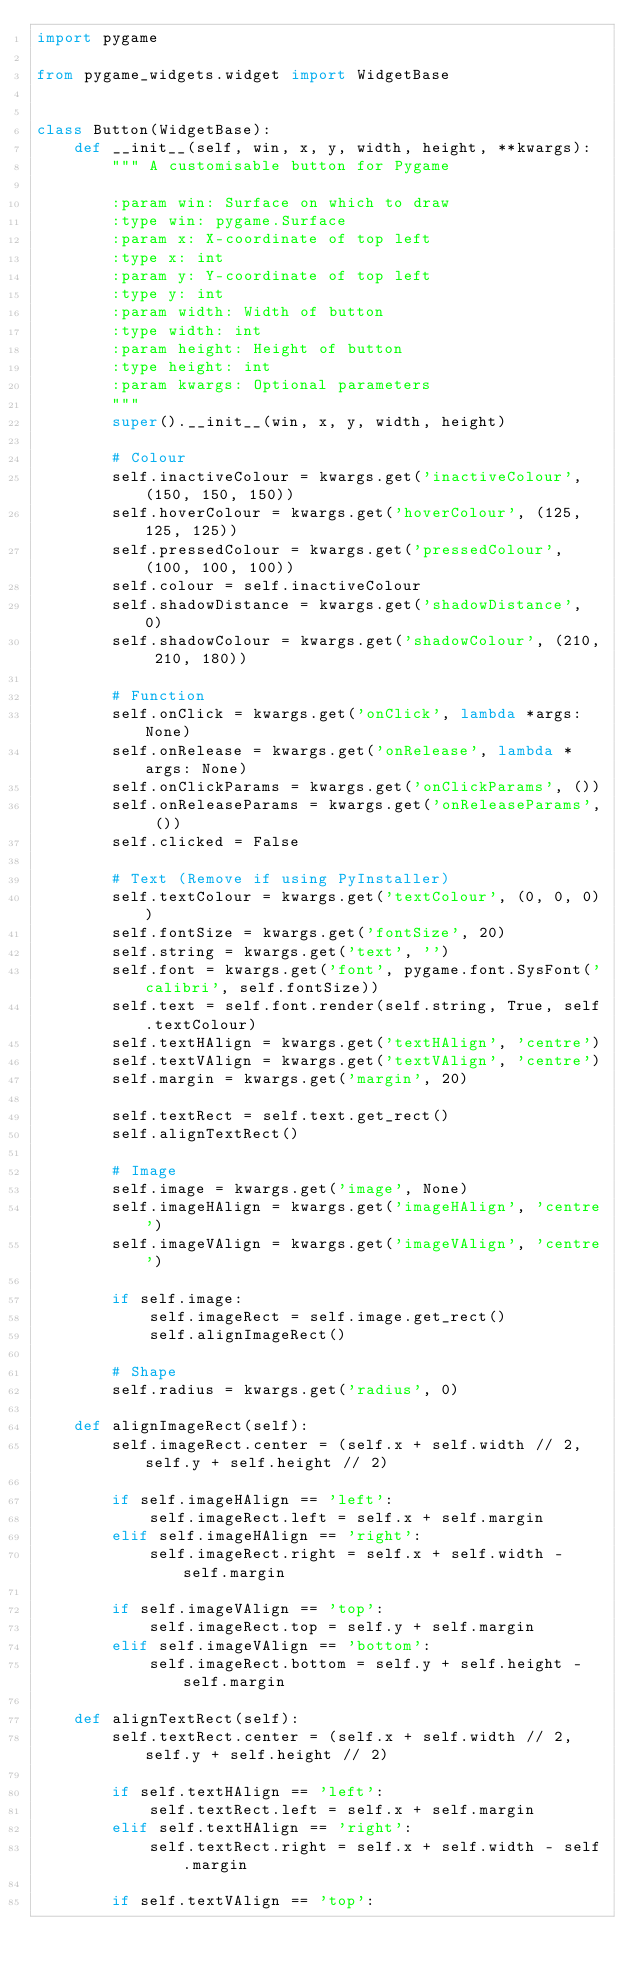Convert code to text. <code><loc_0><loc_0><loc_500><loc_500><_Python_>import pygame

from pygame_widgets.widget import WidgetBase


class Button(WidgetBase):
    def __init__(self, win, x, y, width, height, **kwargs):
        """ A customisable button for Pygame

        :param win: Surface on which to draw
        :type win: pygame.Surface
        :param x: X-coordinate of top left
        :type x: int
        :param y: Y-coordinate of top left
        :type y: int
        :param width: Width of button
        :type width: int
        :param height: Height of button
        :type height: int
        :param kwargs: Optional parameters
        """
        super().__init__(win, x, y, width, height)

        # Colour
        self.inactiveColour = kwargs.get('inactiveColour', (150, 150, 150))
        self.hoverColour = kwargs.get('hoverColour', (125, 125, 125))
        self.pressedColour = kwargs.get('pressedColour', (100, 100, 100))
        self.colour = self.inactiveColour
        self.shadowDistance = kwargs.get('shadowDistance', 0)
        self.shadowColour = kwargs.get('shadowColour', (210, 210, 180))

        # Function
        self.onClick = kwargs.get('onClick', lambda *args: None)
        self.onRelease = kwargs.get('onRelease', lambda *args: None)
        self.onClickParams = kwargs.get('onClickParams', ())
        self.onReleaseParams = kwargs.get('onReleaseParams', ())
        self.clicked = False

        # Text (Remove if using PyInstaller)
        self.textColour = kwargs.get('textColour', (0, 0, 0))
        self.fontSize = kwargs.get('fontSize', 20)
        self.string = kwargs.get('text', '')
        self.font = kwargs.get('font', pygame.font.SysFont('calibri', self.fontSize))
        self.text = self.font.render(self.string, True, self.textColour)
        self.textHAlign = kwargs.get('textHAlign', 'centre')
        self.textVAlign = kwargs.get('textVAlign', 'centre')
        self.margin = kwargs.get('margin', 20)

        self.textRect = self.text.get_rect()
        self.alignTextRect()

        # Image
        self.image = kwargs.get('image', None)
        self.imageHAlign = kwargs.get('imageHAlign', 'centre')
        self.imageVAlign = kwargs.get('imageVAlign', 'centre')

        if self.image:
            self.imageRect = self.image.get_rect()
            self.alignImageRect()

        # Shape
        self.radius = kwargs.get('radius', 0)

    def alignImageRect(self):
        self.imageRect.center = (self.x + self.width // 2, self.y + self.height // 2)

        if self.imageHAlign == 'left':
            self.imageRect.left = self.x + self.margin
        elif self.imageHAlign == 'right':
            self.imageRect.right = self.x + self.width - self.margin

        if self.imageVAlign == 'top':
            self.imageRect.top = self.y + self.margin
        elif self.imageVAlign == 'bottom':
            self.imageRect.bottom = self.y + self.height - self.margin

    def alignTextRect(self):
        self.textRect.center = (self.x + self.width // 2, self.y + self.height // 2)

        if self.textHAlign == 'left':
            self.textRect.left = self.x + self.margin
        elif self.textHAlign == 'right':
            self.textRect.right = self.x + self.width - self.margin

        if self.textVAlign == 'top':</code> 